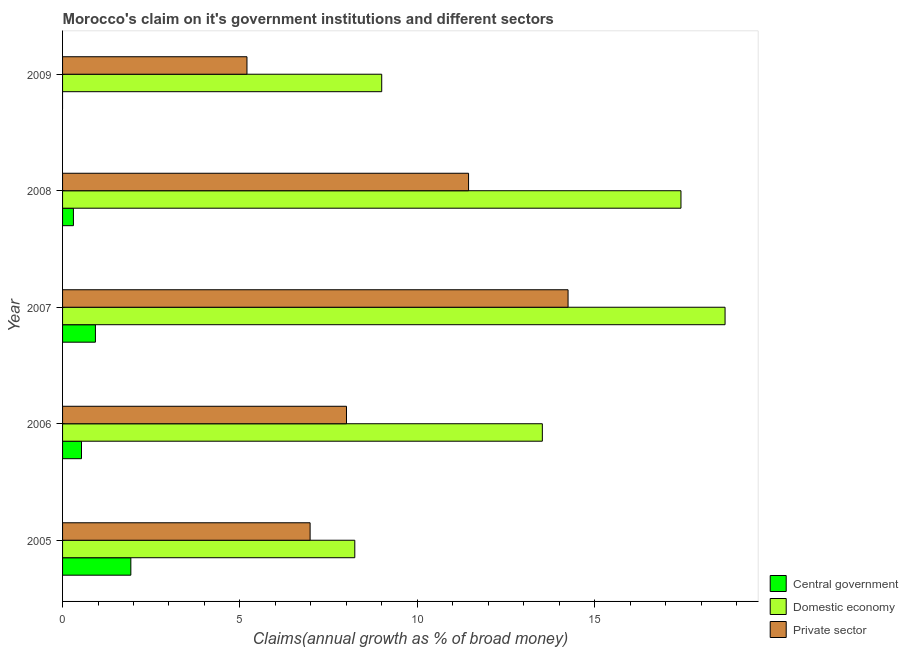How many different coloured bars are there?
Offer a very short reply. 3. Are the number of bars on each tick of the Y-axis equal?
Provide a short and direct response. No. What is the percentage of claim on the domestic economy in 2007?
Your answer should be very brief. 18.68. Across all years, what is the maximum percentage of claim on the private sector?
Your answer should be very brief. 14.25. Across all years, what is the minimum percentage of claim on the domestic economy?
Make the answer very short. 8.24. In which year was the percentage of claim on the private sector maximum?
Offer a very short reply. 2007. What is the total percentage of claim on the domestic economy in the graph?
Make the answer very short. 66.87. What is the difference between the percentage of claim on the domestic economy in 2005 and that in 2008?
Ensure brevity in your answer.  -9.2. What is the difference between the percentage of claim on the domestic economy in 2006 and the percentage of claim on the private sector in 2007?
Give a very brief answer. -0.73. What is the average percentage of claim on the domestic economy per year?
Offer a terse response. 13.38. In the year 2008, what is the difference between the percentage of claim on the private sector and percentage of claim on the domestic economy?
Your response must be concise. -5.99. What is the ratio of the percentage of claim on the domestic economy in 2007 to that in 2009?
Make the answer very short. 2.08. Is the difference between the percentage of claim on the domestic economy in 2005 and 2007 greater than the difference between the percentage of claim on the private sector in 2005 and 2007?
Give a very brief answer. No. What is the difference between the highest and the second highest percentage of claim on the domestic economy?
Your response must be concise. 1.24. What is the difference between the highest and the lowest percentage of claim on the central government?
Offer a very short reply. 1.92. In how many years, is the percentage of claim on the central government greater than the average percentage of claim on the central government taken over all years?
Your answer should be compact. 2. Are all the bars in the graph horizontal?
Offer a very short reply. Yes. What is the difference between two consecutive major ticks on the X-axis?
Keep it short and to the point. 5. Are the values on the major ticks of X-axis written in scientific E-notation?
Your answer should be compact. No. Does the graph contain any zero values?
Ensure brevity in your answer.  Yes. Does the graph contain grids?
Provide a short and direct response. No. Where does the legend appear in the graph?
Your answer should be very brief. Bottom right. How are the legend labels stacked?
Ensure brevity in your answer.  Vertical. What is the title of the graph?
Your answer should be compact. Morocco's claim on it's government institutions and different sectors. What is the label or title of the X-axis?
Provide a succinct answer. Claims(annual growth as % of broad money). What is the Claims(annual growth as % of broad money) in Central government in 2005?
Provide a succinct answer. 1.92. What is the Claims(annual growth as % of broad money) of Domestic economy in 2005?
Offer a terse response. 8.24. What is the Claims(annual growth as % of broad money) of Private sector in 2005?
Give a very brief answer. 6.98. What is the Claims(annual growth as % of broad money) of Central government in 2006?
Provide a succinct answer. 0.53. What is the Claims(annual growth as % of broad money) of Domestic economy in 2006?
Your answer should be very brief. 13.53. What is the Claims(annual growth as % of broad money) in Private sector in 2006?
Keep it short and to the point. 8. What is the Claims(annual growth as % of broad money) in Central government in 2007?
Offer a terse response. 0.93. What is the Claims(annual growth as % of broad money) in Domestic economy in 2007?
Keep it short and to the point. 18.68. What is the Claims(annual growth as % of broad money) in Private sector in 2007?
Your answer should be very brief. 14.25. What is the Claims(annual growth as % of broad money) in Central government in 2008?
Your answer should be compact. 0.31. What is the Claims(annual growth as % of broad money) of Domestic economy in 2008?
Your answer should be compact. 17.43. What is the Claims(annual growth as % of broad money) in Private sector in 2008?
Ensure brevity in your answer.  11.45. What is the Claims(annual growth as % of broad money) of Central government in 2009?
Keep it short and to the point. 0. What is the Claims(annual growth as % of broad money) in Domestic economy in 2009?
Ensure brevity in your answer.  9. What is the Claims(annual growth as % of broad money) in Private sector in 2009?
Your answer should be compact. 5.2. Across all years, what is the maximum Claims(annual growth as % of broad money) in Central government?
Offer a terse response. 1.92. Across all years, what is the maximum Claims(annual growth as % of broad money) in Domestic economy?
Give a very brief answer. 18.68. Across all years, what is the maximum Claims(annual growth as % of broad money) of Private sector?
Offer a terse response. 14.25. Across all years, what is the minimum Claims(annual growth as % of broad money) of Domestic economy?
Provide a succinct answer. 8.24. Across all years, what is the minimum Claims(annual growth as % of broad money) in Private sector?
Your answer should be compact. 5.2. What is the total Claims(annual growth as % of broad money) in Central government in the graph?
Offer a terse response. 3.69. What is the total Claims(annual growth as % of broad money) in Domestic economy in the graph?
Your response must be concise. 66.87. What is the total Claims(annual growth as % of broad money) in Private sector in the graph?
Give a very brief answer. 45.88. What is the difference between the Claims(annual growth as % of broad money) of Central government in 2005 and that in 2006?
Make the answer very short. 1.39. What is the difference between the Claims(annual growth as % of broad money) of Domestic economy in 2005 and that in 2006?
Your answer should be very brief. -5.29. What is the difference between the Claims(annual growth as % of broad money) of Private sector in 2005 and that in 2006?
Give a very brief answer. -1.03. What is the difference between the Claims(annual growth as % of broad money) in Domestic economy in 2005 and that in 2007?
Your response must be concise. -10.44. What is the difference between the Claims(annual growth as % of broad money) in Private sector in 2005 and that in 2007?
Keep it short and to the point. -7.27. What is the difference between the Claims(annual growth as % of broad money) of Central government in 2005 and that in 2008?
Ensure brevity in your answer.  1.62. What is the difference between the Claims(annual growth as % of broad money) of Domestic economy in 2005 and that in 2008?
Your response must be concise. -9.2. What is the difference between the Claims(annual growth as % of broad money) of Private sector in 2005 and that in 2008?
Offer a very short reply. -4.47. What is the difference between the Claims(annual growth as % of broad money) in Domestic economy in 2005 and that in 2009?
Provide a succinct answer. -0.76. What is the difference between the Claims(annual growth as % of broad money) in Private sector in 2005 and that in 2009?
Provide a succinct answer. 1.78. What is the difference between the Claims(annual growth as % of broad money) in Central government in 2006 and that in 2007?
Your answer should be compact. -0.39. What is the difference between the Claims(annual growth as % of broad money) of Domestic economy in 2006 and that in 2007?
Your answer should be very brief. -5.15. What is the difference between the Claims(annual growth as % of broad money) of Private sector in 2006 and that in 2007?
Your answer should be very brief. -6.25. What is the difference between the Claims(annual growth as % of broad money) in Central government in 2006 and that in 2008?
Give a very brief answer. 0.23. What is the difference between the Claims(annual growth as % of broad money) in Domestic economy in 2006 and that in 2008?
Provide a short and direct response. -3.91. What is the difference between the Claims(annual growth as % of broad money) of Private sector in 2006 and that in 2008?
Make the answer very short. -3.44. What is the difference between the Claims(annual growth as % of broad money) in Domestic economy in 2006 and that in 2009?
Make the answer very short. 4.53. What is the difference between the Claims(annual growth as % of broad money) of Private sector in 2006 and that in 2009?
Give a very brief answer. 2.81. What is the difference between the Claims(annual growth as % of broad money) in Central government in 2007 and that in 2008?
Your answer should be compact. 0.62. What is the difference between the Claims(annual growth as % of broad money) in Domestic economy in 2007 and that in 2008?
Give a very brief answer. 1.24. What is the difference between the Claims(annual growth as % of broad money) in Private sector in 2007 and that in 2008?
Make the answer very short. 2.81. What is the difference between the Claims(annual growth as % of broad money) of Domestic economy in 2007 and that in 2009?
Provide a succinct answer. 9.68. What is the difference between the Claims(annual growth as % of broad money) of Private sector in 2007 and that in 2009?
Provide a short and direct response. 9.05. What is the difference between the Claims(annual growth as % of broad money) of Domestic economy in 2008 and that in 2009?
Provide a succinct answer. 8.44. What is the difference between the Claims(annual growth as % of broad money) of Private sector in 2008 and that in 2009?
Offer a terse response. 6.25. What is the difference between the Claims(annual growth as % of broad money) of Central government in 2005 and the Claims(annual growth as % of broad money) of Domestic economy in 2006?
Ensure brevity in your answer.  -11.6. What is the difference between the Claims(annual growth as % of broad money) in Central government in 2005 and the Claims(annual growth as % of broad money) in Private sector in 2006?
Ensure brevity in your answer.  -6.08. What is the difference between the Claims(annual growth as % of broad money) of Domestic economy in 2005 and the Claims(annual growth as % of broad money) of Private sector in 2006?
Keep it short and to the point. 0.23. What is the difference between the Claims(annual growth as % of broad money) of Central government in 2005 and the Claims(annual growth as % of broad money) of Domestic economy in 2007?
Offer a very short reply. -16.75. What is the difference between the Claims(annual growth as % of broad money) of Central government in 2005 and the Claims(annual growth as % of broad money) of Private sector in 2007?
Give a very brief answer. -12.33. What is the difference between the Claims(annual growth as % of broad money) of Domestic economy in 2005 and the Claims(annual growth as % of broad money) of Private sector in 2007?
Make the answer very short. -6.01. What is the difference between the Claims(annual growth as % of broad money) in Central government in 2005 and the Claims(annual growth as % of broad money) in Domestic economy in 2008?
Your response must be concise. -15.51. What is the difference between the Claims(annual growth as % of broad money) in Central government in 2005 and the Claims(annual growth as % of broad money) in Private sector in 2008?
Give a very brief answer. -9.52. What is the difference between the Claims(annual growth as % of broad money) of Domestic economy in 2005 and the Claims(annual growth as % of broad money) of Private sector in 2008?
Ensure brevity in your answer.  -3.21. What is the difference between the Claims(annual growth as % of broad money) of Central government in 2005 and the Claims(annual growth as % of broad money) of Domestic economy in 2009?
Make the answer very short. -7.07. What is the difference between the Claims(annual growth as % of broad money) in Central government in 2005 and the Claims(annual growth as % of broad money) in Private sector in 2009?
Your response must be concise. -3.27. What is the difference between the Claims(annual growth as % of broad money) in Domestic economy in 2005 and the Claims(annual growth as % of broad money) in Private sector in 2009?
Your answer should be compact. 3.04. What is the difference between the Claims(annual growth as % of broad money) of Central government in 2006 and the Claims(annual growth as % of broad money) of Domestic economy in 2007?
Your answer should be compact. -18.14. What is the difference between the Claims(annual growth as % of broad money) of Central government in 2006 and the Claims(annual growth as % of broad money) of Private sector in 2007?
Your response must be concise. -13.72. What is the difference between the Claims(annual growth as % of broad money) in Domestic economy in 2006 and the Claims(annual growth as % of broad money) in Private sector in 2007?
Make the answer very short. -0.73. What is the difference between the Claims(annual growth as % of broad money) in Central government in 2006 and the Claims(annual growth as % of broad money) in Domestic economy in 2008?
Your answer should be very brief. -16.9. What is the difference between the Claims(annual growth as % of broad money) of Central government in 2006 and the Claims(annual growth as % of broad money) of Private sector in 2008?
Offer a very short reply. -10.91. What is the difference between the Claims(annual growth as % of broad money) in Domestic economy in 2006 and the Claims(annual growth as % of broad money) in Private sector in 2008?
Your answer should be compact. 2.08. What is the difference between the Claims(annual growth as % of broad money) in Central government in 2006 and the Claims(annual growth as % of broad money) in Domestic economy in 2009?
Ensure brevity in your answer.  -8.46. What is the difference between the Claims(annual growth as % of broad money) of Central government in 2006 and the Claims(annual growth as % of broad money) of Private sector in 2009?
Your response must be concise. -4.66. What is the difference between the Claims(annual growth as % of broad money) in Domestic economy in 2006 and the Claims(annual growth as % of broad money) in Private sector in 2009?
Your answer should be compact. 8.33. What is the difference between the Claims(annual growth as % of broad money) of Central government in 2007 and the Claims(annual growth as % of broad money) of Domestic economy in 2008?
Your answer should be compact. -16.51. What is the difference between the Claims(annual growth as % of broad money) of Central government in 2007 and the Claims(annual growth as % of broad money) of Private sector in 2008?
Your response must be concise. -10.52. What is the difference between the Claims(annual growth as % of broad money) in Domestic economy in 2007 and the Claims(annual growth as % of broad money) in Private sector in 2008?
Offer a terse response. 7.23. What is the difference between the Claims(annual growth as % of broad money) of Central government in 2007 and the Claims(annual growth as % of broad money) of Domestic economy in 2009?
Keep it short and to the point. -8.07. What is the difference between the Claims(annual growth as % of broad money) of Central government in 2007 and the Claims(annual growth as % of broad money) of Private sector in 2009?
Your response must be concise. -4.27. What is the difference between the Claims(annual growth as % of broad money) of Domestic economy in 2007 and the Claims(annual growth as % of broad money) of Private sector in 2009?
Keep it short and to the point. 13.48. What is the difference between the Claims(annual growth as % of broad money) of Central government in 2008 and the Claims(annual growth as % of broad money) of Domestic economy in 2009?
Make the answer very short. -8.69. What is the difference between the Claims(annual growth as % of broad money) of Central government in 2008 and the Claims(annual growth as % of broad money) of Private sector in 2009?
Keep it short and to the point. -4.89. What is the difference between the Claims(annual growth as % of broad money) in Domestic economy in 2008 and the Claims(annual growth as % of broad money) in Private sector in 2009?
Keep it short and to the point. 12.24. What is the average Claims(annual growth as % of broad money) of Central government per year?
Offer a terse response. 0.74. What is the average Claims(annual growth as % of broad money) of Domestic economy per year?
Make the answer very short. 13.37. What is the average Claims(annual growth as % of broad money) of Private sector per year?
Make the answer very short. 9.18. In the year 2005, what is the difference between the Claims(annual growth as % of broad money) of Central government and Claims(annual growth as % of broad money) of Domestic economy?
Make the answer very short. -6.31. In the year 2005, what is the difference between the Claims(annual growth as % of broad money) of Central government and Claims(annual growth as % of broad money) of Private sector?
Ensure brevity in your answer.  -5.05. In the year 2005, what is the difference between the Claims(annual growth as % of broad money) in Domestic economy and Claims(annual growth as % of broad money) in Private sector?
Your answer should be very brief. 1.26. In the year 2006, what is the difference between the Claims(annual growth as % of broad money) in Central government and Claims(annual growth as % of broad money) in Domestic economy?
Offer a very short reply. -12.99. In the year 2006, what is the difference between the Claims(annual growth as % of broad money) in Central government and Claims(annual growth as % of broad money) in Private sector?
Offer a terse response. -7.47. In the year 2006, what is the difference between the Claims(annual growth as % of broad money) of Domestic economy and Claims(annual growth as % of broad money) of Private sector?
Keep it short and to the point. 5.52. In the year 2007, what is the difference between the Claims(annual growth as % of broad money) in Central government and Claims(annual growth as % of broad money) in Domestic economy?
Keep it short and to the point. -17.75. In the year 2007, what is the difference between the Claims(annual growth as % of broad money) in Central government and Claims(annual growth as % of broad money) in Private sector?
Your answer should be very brief. -13.32. In the year 2007, what is the difference between the Claims(annual growth as % of broad money) of Domestic economy and Claims(annual growth as % of broad money) of Private sector?
Keep it short and to the point. 4.43. In the year 2008, what is the difference between the Claims(annual growth as % of broad money) of Central government and Claims(annual growth as % of broad money) of Domestic economy?
Make the answer very short. -17.13. In the year 2008, what is the difference between the Claims(annual growth as % of broad money) in Central government and Claims(annual growth as % of broad money) in Private sector?
Provide a short and direct response. -11.14. In the year 2008, what is the difference between the Claims(annual growth as % of broad money) in Domestic economy and Claims(annual growth as % of broad money) in Private sector?
Your response must be concise. 5.99. In the year 2009, what is the difference between the Claims(annual growth as % of broad money) in Domestic economy and Claims(annual growth as % of broad money) in Private sector?
Your answer should be very brief. 3.8. What is the ratio of the Claims(annual growth as % of broad money) in Central government in 2005 to that in 2006?
Your response must be concise. 3.61. What is the ratio of the Claims(annual growth as % of broad money) of Domestic economy in 2005 to that in 2006?
Make the answer very short. 0.61. What is the ratio of the Claims(annual growth as % of broad money) in Private sector in 2005 to that in 2006?
Your answer should be very brief. 0.87. What is the ratio of the Claims(annual growth as % of broad money) in Central government in 2005 to that in 2007?
Keep it short and to the point. 2.08. What is the ratio of the Claims(annual growth as % of broad money) of Domestic economy in 2005 to that in 2007?
Give a very brief answer. 0.44. What is the ratio of the Claims(annual growth as % of broad money) in Private sector in 2005 to that in 2007?
Provide a short and direct response. 0.49. What is the ratio of the Claims(annual growth as % of broad money) in Central government in 2005 to that in 2008?
Make the answer very short. 6.29. What is the ratio of the Claims(annual growth as % of broad money) of Domestic economy in 2005 to that in 2008?
Your answer should be very brief. 0.47. What is the ratio of the Claims(annual growth as % of broad money) in Private sector in 2005 to that in 2008?
Your answer should be very brief. 0.61. What is the ratio of the Claims(annual growth as % of broad money) of Domestic economy in 2005 to that in 2009?
Your response must be concise. 0.92. What is the ratio of the Claims(annual growth as % of broad money) of Private sector in 2005 to that in 2009?
Offer a very short reply. 1.34. What is the ratio of the Claims(annual growth as % of broad money) in Central government in 2006 to that in 2007?
Keep it short and to the point. 0.58. What is the ratio of the Claims(annual growth as % of broad money) in Domestic economy in 2006 to that in 2007?
Your answer should be compact. 0.72. What is the ratio of the Claims(annual growth as % of broad money) in Private sector in 2006 to that in 2007?
Provide a succinct answer. 0.56. What is the ratio of the Claims(annual growth as % of broad money) of Central government in 2006 to that in 2008?
Offer a very short reply. 1.74. What is the ratio of the Claims(annual growth as % of broad money) of Domestic economy in 2006 to that in 2008?
Offer a terse response. 0.78. What is the ratio of the Claims(annual growth as % of broad money) of Private sector in 2006 to that in 2008?
Give a very brief answer. 0.7. What is the ratio of the Claims(annual growth as % of broad money) in Domestic economy in 2006 to that in 2009?
Keep it short and to the point. 1.5. What is the ratio of the Claims(annual growth as % of broad money) of Private sector in 2006 to that in 2009?
Ensure brevity in your answer.  1.54. What is the ratio of the Claims(annual growth as % of broad money) of Central government in 2007 to that in 2008?
Keep it short and to the point. 3.03. What is the ratio of the Claims(annual growth as % of broad money) of Domestic economy in 2007 to that in 2008?
Keep it short and to the point. 1.07. What is the ratio of the Claims(annual growth as % of broad money) in Private sector in 2007 to that in 2008?
Offer a very short reply. 1.25. What is the ratio of the Claims(annual growth as % of broad money) of Domestic economy in 2007 to that in 2009?
Provide a succinct answer. 2.08. What is the ratio of the Claims(annual growth as % of broad money) of Private sector in 2007 to that in 2009?
Your answer should be very brief. 2.74. What is the ratio of the Claims(annual growth as % of broad money) in Domestic economy in 2008 to that in 2009?
Offer a terse response. 1.94. What is the ratio of the Claims(annual growth as % of broad money) of Private sector in 2008 to that in 2009?
Make the answer very short. 2.2. What is the difference between the highest and the second highest Claims(annual growth as % of broad money) in Central government?
Make the answer very short. 1. What is the difference between the highest and the second highest Claims(annual growth as % of broad money) in Domestic economy?
Make the answer very short. 1.24. What is the difference between the highest and the second highest Claims(annual growth as % of broad money) of Private sector?
Offer a terse response. 2.81. What is the difference between the highest and the lowest Claims(annual growth as % of broad money) of Central government?
Offer a very short reply. 1.92. What is the difference between the highest and the lowest Claims(annual growth as % of broad money) in Domestic economy?
Provide a succinct answer. 10.44. What is the difference between the highest and the lowest Claims(annual growth as % of broad money) in Private sector?
Your response must be concise. 9.05. 